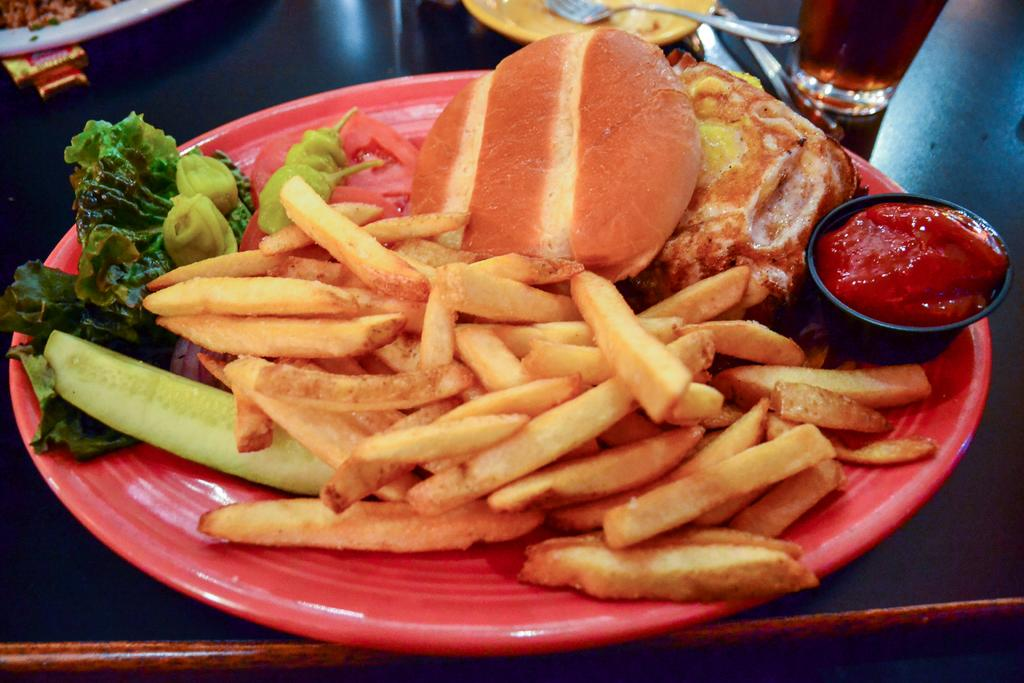What type of food is in the plate in the image? The facts do not specify the type of food in the plate. What type of food is in the bowl in the image? The facts do not specify the type of food in the bowl. What utensil is present in the image? There is a fork in the image. How many plates are visible in the image? There are two plates visible in the image. What is in the glass in the image? There is liquid in the glass in the image. Where are all these items located? All of these items are on a table in the image. What type of crown is worn by the face in the image? There is no face or crown present in the image. What is the income of the person who owns the food in the image? The facts do not provide any information about the income of the person who owns the food in the image. 